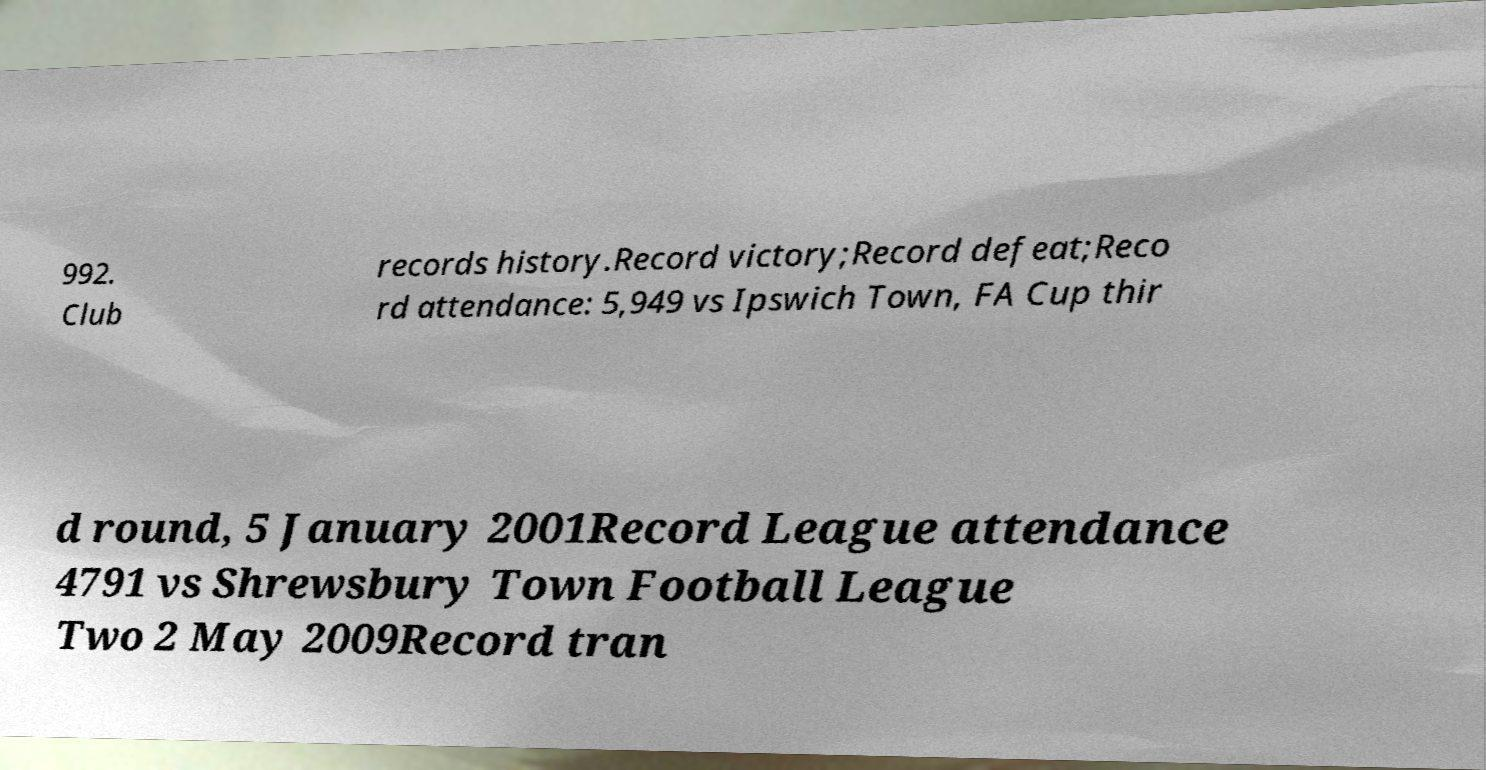What messages or text are displayed in this image? I need them in a readable, typed format. 992. Club records history.Record victory;Record defeat;Reco rd attendance: 5,949 vs Ipswich Town, FA Cup thir d round, 5 January 2001Record League attendance 4791 vs Shrewsbury Town Football League Two 2 May 2009Record tran 